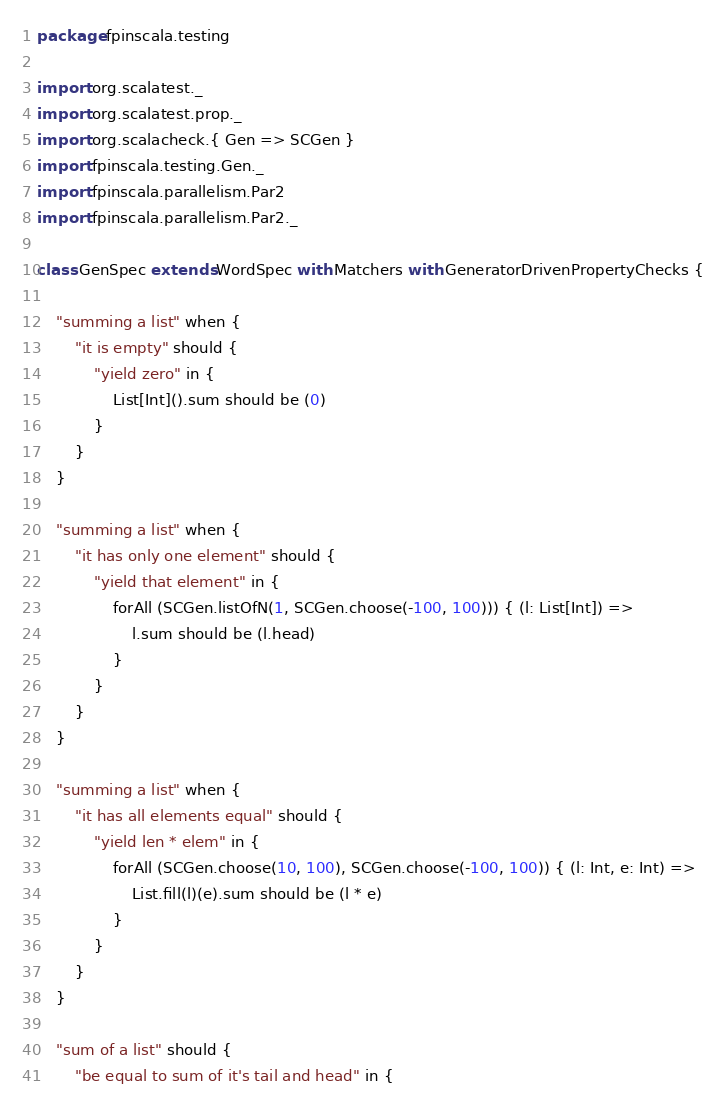Convert code to text. <code><loc_0><loc_0><loc_500><loc_500><_Scala_>package fpinscala.testing

import org.scalatest._
import org.scalatest.prop._
import org.scalacheck.{ Gen => SCGen }
import fpinscala.testing.Gen._
import fpinscala.parallelism.Par2
import fpinscala.parallelism.Par2._

class GenSpec extends WordSpec with Matchers with GeneratorDrivenPropertyChecks {

	"summing a list" when {
		"it is empty" should {
			"yield zero" in {
				List[Int]().sum should be (0)
			}
		}
	}

	"summing a list" when {
		"it has only one element" should {
			"yield that element" in {
				forAll (SCGen.listOfN(1, SCGen.choose(-100, 100))) { (l: List[Int]) =>
					l.sum should be (l.head)
				}
			}
		}
	}

	"summing a list" when {
		"it has all elements equal" should {
			"yield len * elem" in {
				forAll (SCGen.choose(10, 100), SCGen.choose(-100, 100)) { (l: Int, e: Int) =>
					List.fill(l)(e).sum should be (l * e)
				}
			}
		}
	}

	"sum of a list" should {
		"be equal to sum of it's tail and head" in {</code> 